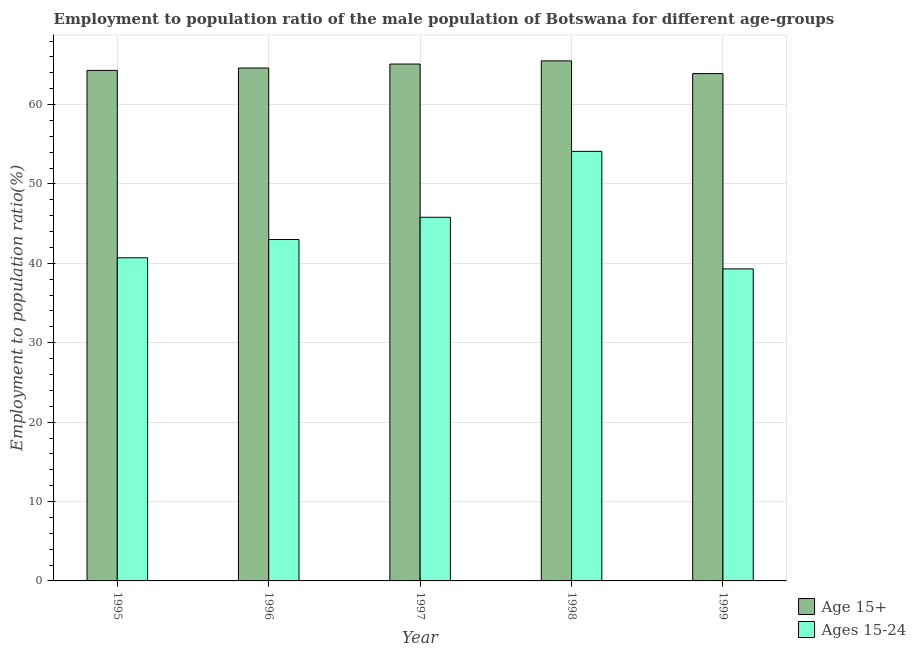How many different coloured bars are there?
Ensure brevity in your answer.  2. Are the number of bars per tick equal to the number of legend labels?
Keep it short and to the point. Yes. Are the number of bars on each tick of the X-axis equal?
Offer a very short reply. Yes. How many bars are there on the 3rd tick from the left?
Your answer should be compact. 2. How many bars are there on the 3rd tick from the right?
Make the answer very short. 2. What is the label of the 1st group of bars from the left?
Provide a short and direct response. 1995. What is the employment to population ratio(age 15+) in 1995?
Offer a very short reply. 64.3. Across all years, what is the maximum employment to population ratio(age 15-24)?
Your answer should be very brief. 54.1. Across all years, what is the minimum employment to population ratio(age 15-24)?
Your answer should be compact. 39.3. What is the total employment to population ratio(age 15-24) in the graph?
Your response must be concise. 222.9. What is the difference between the employment to population ratio(age 15-24) in 1995 and that in 1999?
Give a very brief answer. 1.4. What is the difference between the employment to population ratio(age 15-24) in 1996 and the employment to population ratio(age 15+) in 1998?
Offer a very short reply. -11.1. What is the average employment to population ratio(age 15+) per year?
Provide a short and direct response. 64.68. What is the ratio of the employment to population ratio(age 15-24) in 1996 to that in 1999?
Provide a succinct answer. 1.09. Is the difference between the employment to population ratio(age 15-24) in 1995 and 1998 greater than the difference between the employment to population ratio(age 15+) in 1995 and 1998?
Give a very brief answer. No. What is the difference between the highest and the second highest employment to population ratio(age 15-24)?
Make the answer very short. 8.3. What is the difference between the highest and the lowest employment to population ratio(age 15-24)?
Your answer should be compact. 14.8. Is the sum of the employment to population ratio(age 15+) in 1995 and 1998 greater than the maximum employment to population ratio(age 15-24) across all years?
Your answer should be very brief. Yes. What does the 1st bar from the left in 1996 represents?
Make the answer very short. Age 15+. What does the 1st bar from the right in 1997 represents?
Your response must be concise. Ages 15-24. How many bars are there?
Your answer should be very brief. 10. Are all the bars in the graph horizontal?
Give a very brief answer. No. How many years are there in the graph?
Keep it short and to the point. 5. What is the difference between two consecutive major ticks on the Y-axis?
Provide a short and direct response. 10. Are the values on the major ticks of Y-axis written in scientific E-notation?
Your response must be concise. No. How many legend labels are there?
Keep it short and to the point. 2. What is the title of the graph?
Ensure brevity in your answer.  Employment to population ratio of the male population of Botswana for different age-groups. What is the Employment to population ratio(%) of Age 15+ in 1995?
Provide a succinct answer. 64.3. What is the Employment to population ratio(%) in Ages 15-24 in 1995?
Provide a short and direct response. 40.7. What is the Employment to population ratio(%) in Age 15+ in 1996?
Your answer should be very brief. 64.6. What is the Employment to population ratio(%) in Ages 15-24 in 1996?
Ensure brevity in your answer.  43. What is the Employment to population ratio(%) of Age 15+ in 1997?
Ensure brevity in your answer.  65.1. What is the Employment to population ratio(%) of Ages 15-24 in 1997?
Provide a short and direct response. 45.8. What is the Employment to population ratio(%) of Age 15+ in 1998?
Make the answer very short. 65.5. What is the Employment to population ratio(%) of Ages 15-24 in 1998?
Give a very brief answer. 54.1. What is the Employment to population ratio(%) of Age 15+ in 1999?
Your answer should be compact. 63.9. What is the Employment to population ratio(%) in Ages 15-24 in 1999?
Keep it short and to the point. 39.3. Across all years, what is the maximum Employment to population ratio(%) of Age 15+?
Your response must be concise. 65.5. Across all years, what is the maximum Employment to population ratio(%) in Ages 15-24?
Provide a succinct answer. 54.1. Across all years, what is the minimum Employment to population ratio(%) in Age 15+?
Ensure brevity in your answer.  63.9. Across all years, what is the minimum Employment to population ratio(%) in Ages 15-24?
Provide a short and direct response. 39.3. What is the total Employment to population ratio(%) in Age 15+ in the graph?
Make the answer very short. 323.4. What is the total Employment to population ratio(%) of Ages 15-24 in the graph?
Provide a short and direct response. 222.9. What is the difference between the Employment to population ratio(%) of Age 15+ in 1995 and that in 1996?
Keep it short and to the point. -0.3. What is the difference between the Employment to population ratio(%) of Age 15+ in 1995 and that in 1997?
Offer a terse response. -0.8. What is the difference between the Employment to population ratio(%) in Age 15+ in 1995 and that in 1998?
Your answer should be very brief. -1.2. What is the difference between the Employment to population ratio(%) of Age 15+ in 1995 and that in 1999?
Provide a short and direct response. 0.4. What is the difference between the Employment to population ratio(%) of Ages 15-24 in 1995 and that in 1999?
Make the answer very short. 1.4. What is the difference between the Employment to population ratio(%) in Age 15+ in 1996 and that in 1997?
Offer a very short reply. -0.5. What is the difference between the Employment to population ratio(%) of Ages 15-24 in 1996 and that in 1998?
Ensure brevity in your answer.  -11.1. What is the difference between the Employment to population ratio(%) in Ages 15-24 in 1996 and that in 1999?
Offer a very short reply. 3.7. What is the difference between the Employment to population ratio(%) in Age 15+ in 1997 and that in 1998?
Provide a succinct answer. -0.4. What is the difference between the Employment to population ratio(%) in Age 15+ in 1995 and the Employment to population ratio(%) in Ages 15-24 in 1996?
Your answer should be very brief. 21.3. What is the difference between the Employment to population ratio(%) in Age 15+ in 1995 and the Employment to population ratio(%) in Ages 15-24 in 1997?
Ensure brevity in your answer.  18.5. What is the difference between the Employment to population ratio(%) of Age 15+ in 1995 and the Employment to population ratio(%) of Ages 15-24 in 1998?
Ensure brevity in your answer.  10.2. What is the difference between the Employment to population ratio(%) in Age 15+ in 1996 and the Employment to population ratio(%) in Ages 15-24 in 1999?
Give a very brief answer. 25.3. What is the difference between the Employment to population ratio(%) in Age 15+ in 1997 and the Employment to population ratio(%) in Ages 15-24 in 1999?
Offer a terse response. 25.8. What is the difference between the Employment to population ratio(%) of Age 15+ in 1998 and the Employment to population ratio(%) of Ages 15-24 in 1999?
Your answer should be very brief. 26.2. What is the average Employment to population ratio(%) in Age 15+ per year?
Make the answer very short. 64.68. What is the average Employment to population ratio(%) of Ages 15-24 per year?
Your answer should be compact. 44.58. In the year 1995, what is the difference between the Employment to population ratio(%) in Age 15+ and Employment to population ratio(%) in Ages 15-24?
Make the answer very short. 23.6. In the year 1996, what is the difference between the Employment to population ratio(%) of Age 15+ and Employment to population ratio(%) of Ages 15-24?
Your answer should be very brief. 21.6. In the year 1997, what is the difference between the Employment to population ratio(%) of Age 15+ and Employment to population ratio(%) of Ages 15-24?
Your answer should be compact. 19.3. In the year 1998, what is the difference between the Employment to population ratio(%) in Age 15+ and Employment to population ratio(%) in Ages 15-24?
Keep it short and to the point. 11.4. In the year 1999, what is the difference between the Employment to population ratio(%) in Age 15+ and Employment to population ratio(%) in Ages 15-24?
Your response must be concise. 24.6. What is the ratio of the Employment to population ratio(%) in Age 15+ in 1995 to that in 1996?
Offer a very short reply. 1. What is the ratio of the Employment to population ratio(%) in Ages 15-24 in 1995 to that in 1996?
Your response must be concise. 0.95. What is the ratio of the Employment to population ratio(%) of Age 15+ in 1995 to that in 1997?
Provide a short and direct response. 0.99. What is the ratio of the Employment to population ratio(%) in Ages 15-24 in 1995 to that in 1997?
Your response must be concise. 0.89. What is the ratio of the Employment to population ratio(%) of Age 15+ in 1995 to that in 1998?
Ensure brevity in your answer.  0.98. What is the ratio of the Employment to population ratio(%) of Ages 15-24 in 1995 to that in 1998?
Offer a very short reply. 0.75. What is the ratio of the Employment to population ratio(%) of Age 15+ in 1995 to that in 1999?
Your answer should be compact. 1.01. What is the ratio of the Employment to population ratio(%) in Ages 15-24 in 1995 to that in 1999?
Provide a short and direct response. 1.04. What is the ratio of the Employment to population ratio(%) of Ages 15-24 in 1996 to that in 1997?
Give a very brief answer. 0.94. What is the ratio of the Employment to population ratio(%) of Age 15+ in 1996 to that in 1998?
Provide a succinct answer. 0.99. What is the ratio of the Employment to population ratio(%) of Ages 15-24 in 1996 to that in 1998?
Your answer should be compact. 0.79. What is the ratio of the Employment to population ratio(%) of Age 15+ in 1996 to that in 1999?
Give a very brief answer. 1.01. What is the ratio of the Employment to population ratio(%) in Ages 15-24 in 1996 to that in 1999?
Provide a short and direct response. 1.09. What is the ratio of the Employment to population ratio(%) of Age 15+ in 1997 to that in 1998?
Provide a succinct answer. 0.99. What is the ratio of the Employment to population ratio(%) in Ages 15-24 in 1997 to that in 1998?
Offer a very short reply. 0.85. What is the ratio of the Employment to population ratio(%) of Age 15+ in 1997 to that in 1999?
Give a very brief answer. 1.02. What is the ratio of the Employment to population ratio(%) of Ages 15-24 in 1997 to that in 1999?
Keep it short and to the point. 1.17. What is the ratio of the Employment to population ratio(%) of Age 15+ in 1998 to that in 1999?
Give a very brief answer. 1.02. What is the ratio of the Employment to population ratio(%) of Ages 15-24 in 1998 to that in 1999?
Give a very brief answer. 1.38. What is the difference between the highest and the second highest Employment to population ratio(%) of Age 15+?
Make the answer very short. 0.4. What is the difference between the highest and the second highest Employment to population ratio(%) in Ages 15-24?
Provide a succinct answer. 8.3. What is the difference between the highest and the lowest Employment to population ratio(%) in Age 15+?
Provide a succinct answer. 1.6. 